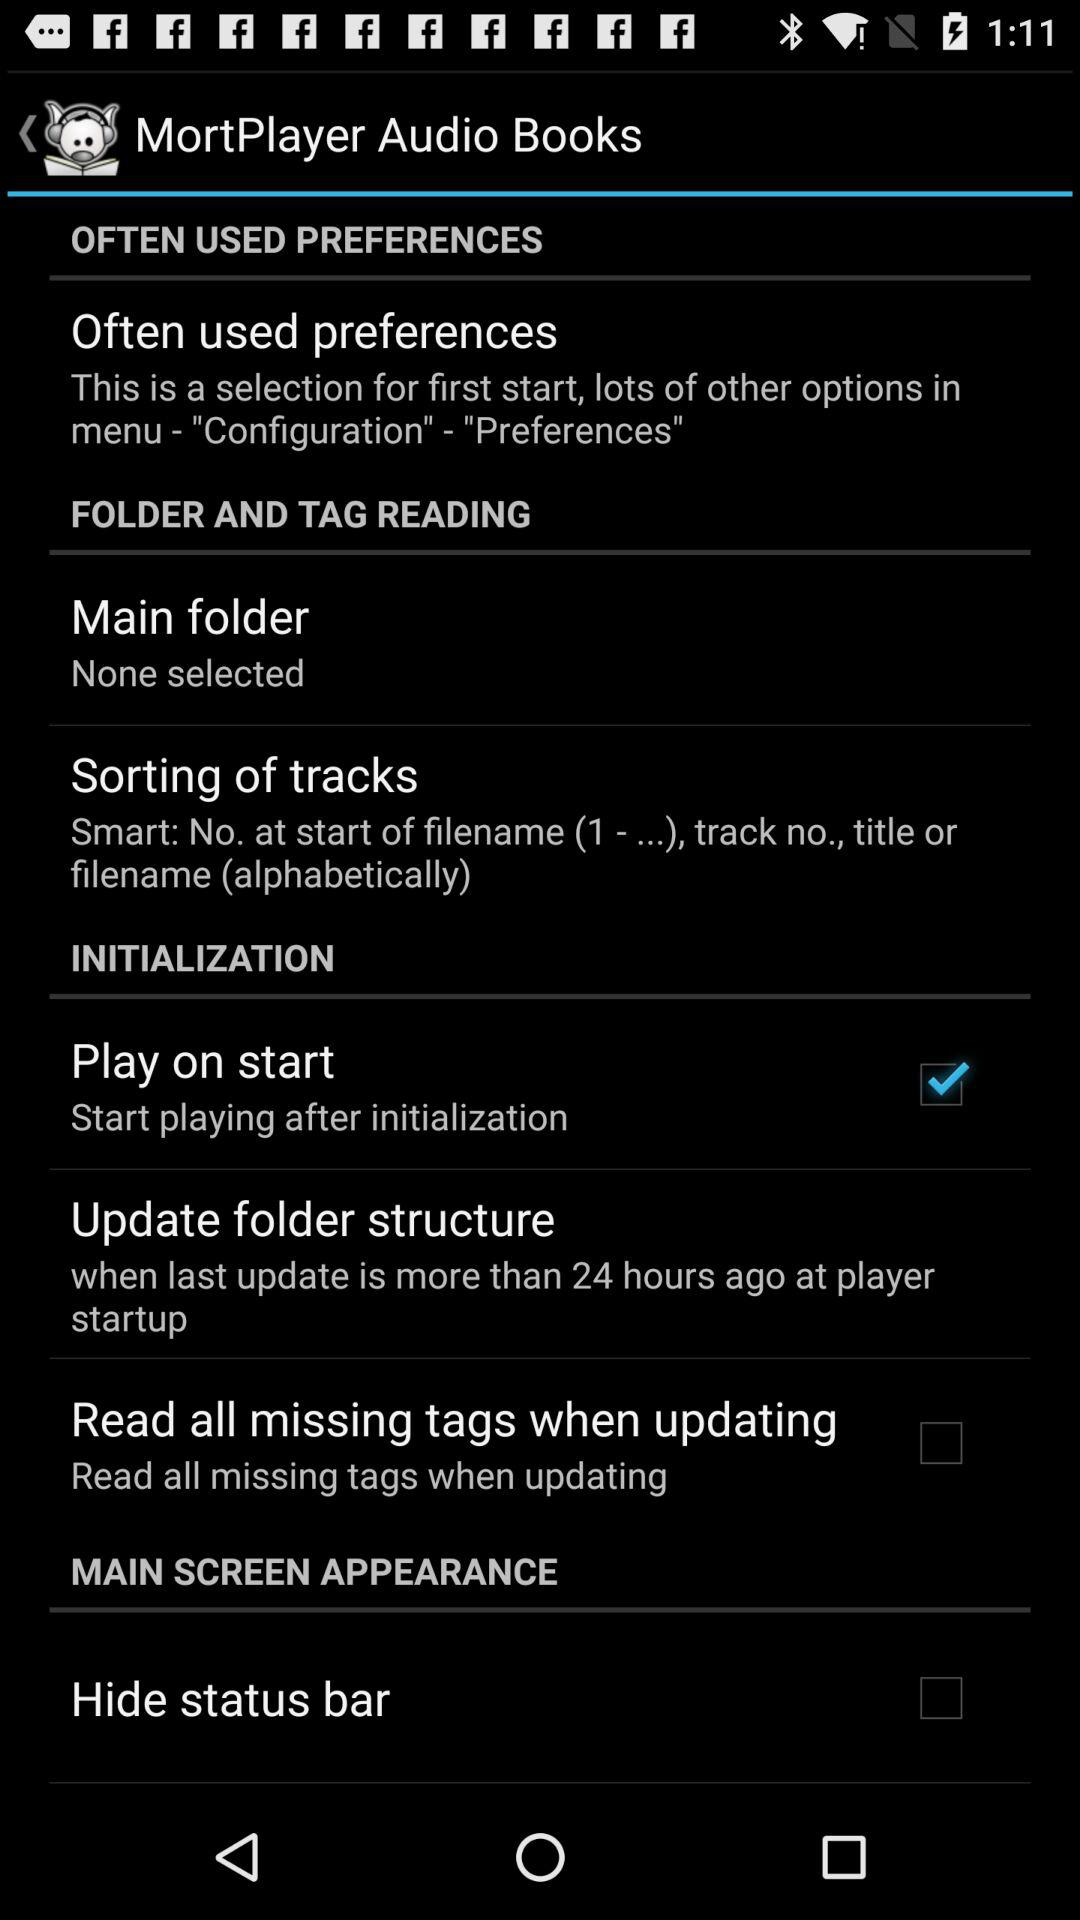What is the setting for the update folder structure? The setting for the update folder structure is "when last update is more than 24 hours ago at player startup". 